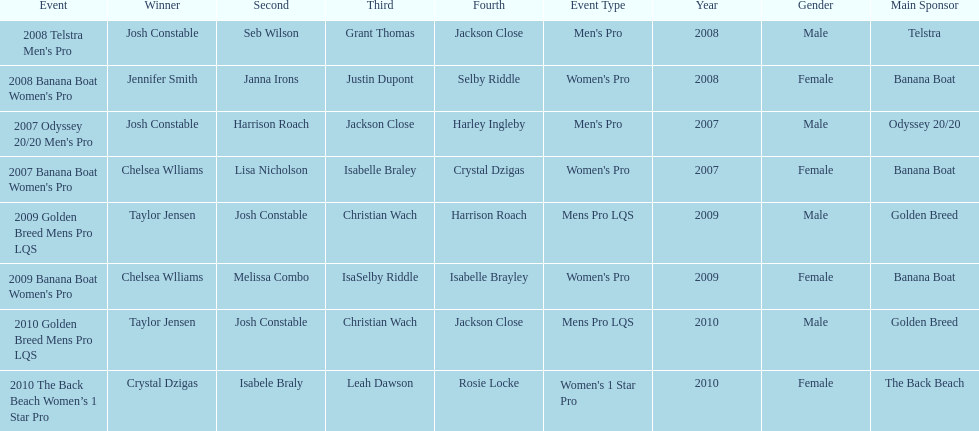Name each of the years that taylor jensen was winner. 2009, 2010. Write the full table. {'header': ['Event', 'Winner', 'Second', 'Third', 'Fourth', 'Event Type', 'Year', 'Gender', 'Main Sponsor'], 'rows': [["2008 Telstra Men's Pro", 'Josh Constable', 'Seb Wilson', 'Grant Thomas', 'Jackson Close', "Men's Pro", '2008', 'Male', 'Telstra'], ["2008 Banana Boat Women's Pro", 'Jennifer Smith', 'Janna Irons', 'Justin Dupont', 'Selby Riddle', "Women's Pro", '2008', 'Female', 'Banana Boat'], ["2007 Odyssey 20/20 Men's Pro", 'Josh Constable', 'Harrison Roach', 'Jackson Close', 'Harley Ingleby', "Men's Pro", '2007', 'Male', 'Odyssey 20/20'], ["2007 Banana Boat Women's Pro", 'Chelsea Wlliams', 'Lisa Nicholson', 'Isabelle Braley', 'Crystal Dzigas', "Women's Pro", '2007', 'Female', 'Banana Boat'], ['2009 Golden Breed Mens Pro LQS', 'Taylor Jensen', 'Josh Constable', 'Christian Wach', 'Harrison Roach', 'Mens Pro LQS', '2009', 'Male', 'Golden Breed'], ["2009 Banana Boat Women's Pro", 'Chelsea Wlliams', 'Melissa Combo', 'IsaSelby Riddle', 'Isabelle Brayley', "Women's Pro", '2009', 'Female', 'Banana Boat'], ['2010 Golden Breed Mens Pro LQS', 'Taylor Jensen', 'Josh Constable', 'Christian Wach', 'Jackson Close', 'Mens Pro LQS', '2010', 'Male', 'Golden Breed'], ['2010 The Back Beach Women’s 1 Star Pro', 'Crystal Dzigas', 'Isabele Braly', 'Leah Dawson', 'Rosie Locke', "Women's 1 Star Pro", '2010', 'Female', 'The Back Beach']]} 